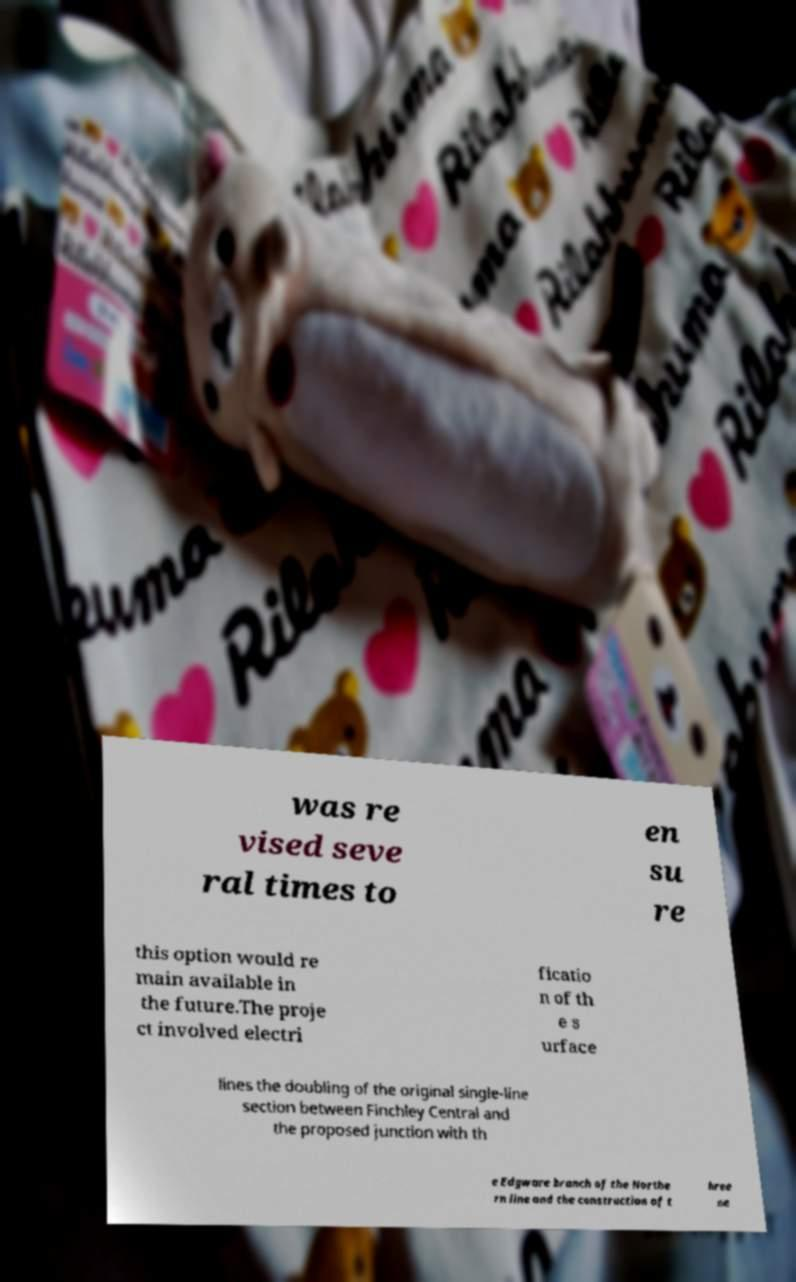I need the written content from this picture converted into text. Can you do that? was re vised seve ral times to en su re this option would re main available in the future.The proje ct involved electri ficatio n of th e s urface lines the doubling of the original single-line section between Finchley Central and the proposed junction with th e Edgware branch of the Northe rn line and the construction of t hree ne 